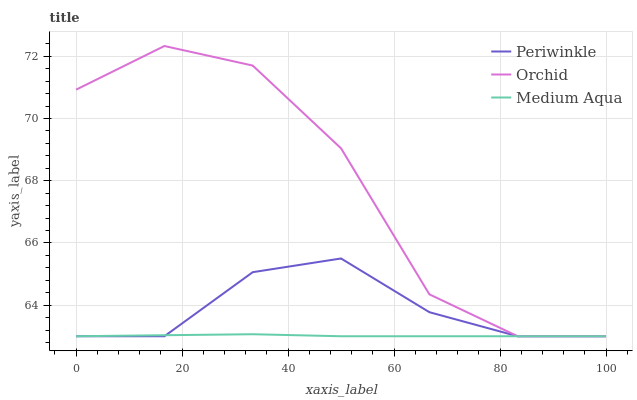Does Medium Aqua have the minimum area under the curve?
Answer yes or no. Yes. Does Orchid have the maximum area under the curve?
Answer yes or no. Yes. Does Periwinkle have the minimum area under the curve?
Answer yes or no. No. Does Periwinkle have the maximum area under the curve?
Answer yes or no. No. Is Medium Aqua the smoothest?
Answer yes or no. Yes. Is Orchid the roughest?
Answer yes or no. Yes. Is Periwinkle the smoothest?
Answer yes or no. No. Is Periwinkle the roughest?
Answer yes or no. No. Does Medium Aqua have the lowest value?
Answer yes or no. Yes. Does Orchid have the highest value?
Answer yes or no. Yes. Does Periwinkle have the highest value?
Answer yes or no. No. Does Orchid intersect Medium Aqua?
Answer yes or no. Yes. Is Orchid less than Medium Aqua?
Answer yes or no. No. Is Orchid greater than Medium Aqua?
Answer yes or no. No. 